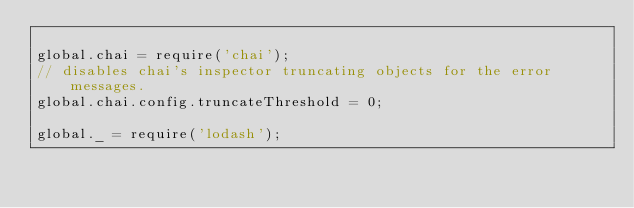Convert code to text. <code><loc_0><loc_0><loc_500><loc_500><_JavaScript_>
global.chai = require('chai');
// disables chai's inspector truncating objects for the error messages.
global.chai.config.truncateThreshold = 0;

global._ = require('lodash');
</code> 